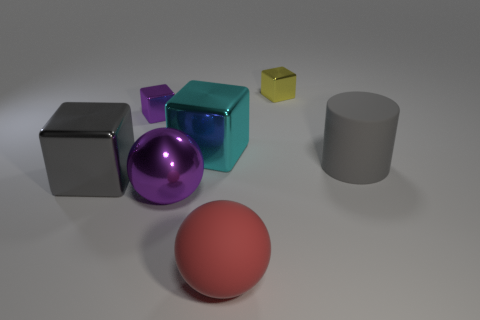Is there any other thing that is the same shape as the gray matte object?
Offer a terse response. No. There is a metallic block on the left side of the tiny thing on the left side of the purple shiny sphere right of the large gray metallic cube; what is its size?
Provide a succinct answer. Large. Is there a yellow object made of the same material as the small yellow cube?
Give a very brief answer. No. There is a red object; what shape is it?
Offer a terse response. Sphere. The small cube that is the same material as the tiny purple thing is what color?
Keep it short and to the point. Yellow. What number of gray things are rubber cylinders or big matte balls?
Provide a succinct answer. 1. Are there more large gray matte things than small blocks?
Provide a short and direct response. No. How many objects are shiny objects that are in front of the cyan object or big red rubber objects that are left of the tiny yellow metallic object?
Provide a succinct answer. 3. There is a metallic ball that is the same size as the cyan shiny object; what color is it?
Make the answer very short. Purple. Are the large cyan object and the big purple object made of the same material?
Your response must be concise. Yes. 